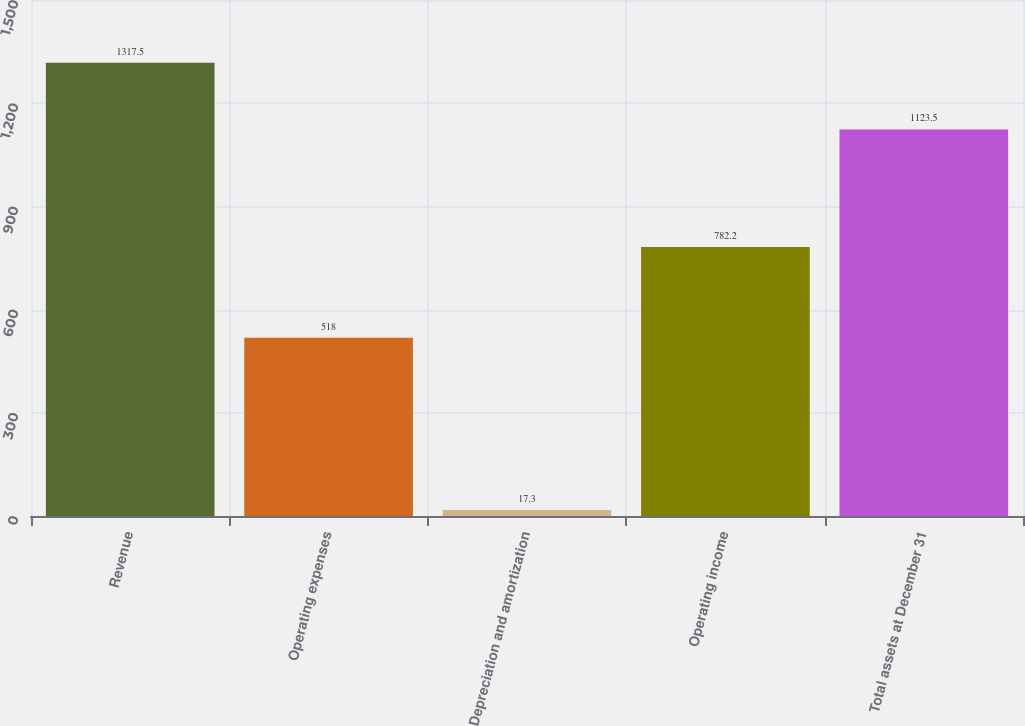<chart> <loc_0><loc_0><loc_500><loc_500><bar_chart><fcel>Revenue<fcel>Operating expenses<fcel>Depreciation and amortization<fcel>Operating income<fcel>Total assets at December 31<nl><fcel>1317.5<fcel>518<fcel>17.3<fcel>782.2<fcel>1123.5<nl></chart> 